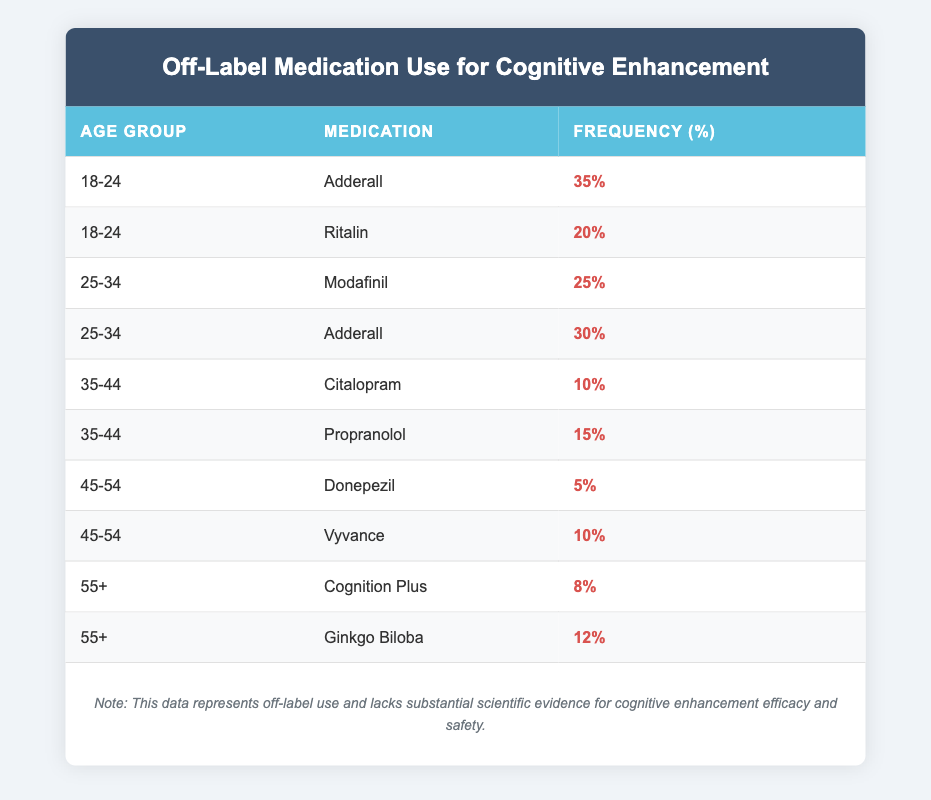What is the highest frequency of off-label medication use for cognitive enhancement in the age group 18-24? In the age group 18-24, the highest frequency is from Adderall, which is 35%. This information can be retrieved directly from the table.
Answer: 35% Which medication is used off-label for cognitive enhancement by the 35-44 age group with the highest frequency? In the 35-44 age group, Propranolol has the highest off-label use frequency at 15%. This is found by comparing the frequencies of available medications in that age group.
Answer: Propranolol What is the total off-label use frequency for Adderall among all age groups? The frequency for Adderall in the age groups is 35% (18-24) and 30% (25-34). Adding these gives a total of 35 + 30 = 65%.
Answer: 65% Is it true that the frequency of off-label use for Donepezil is higher than that for Vyvance in the 45-54 age group? In the table, Donepezil has a frequency of 5% and Vyvance has a frequency of 10%. Since 5% is not higher than 10%, the statement is false.
Answer: No What is the average frequency of cognitive enhancement off-label use across all age groups for Ginkgo Biloba and Cognition Plus? The frequencies for Ginkgo Biloba (12%) and Cognition Plus (8%) are added together, resulting in 12 + 8 = 20%. Dividing by the two data points gives an average of 20/2 = 10%.
Answer: 10% 